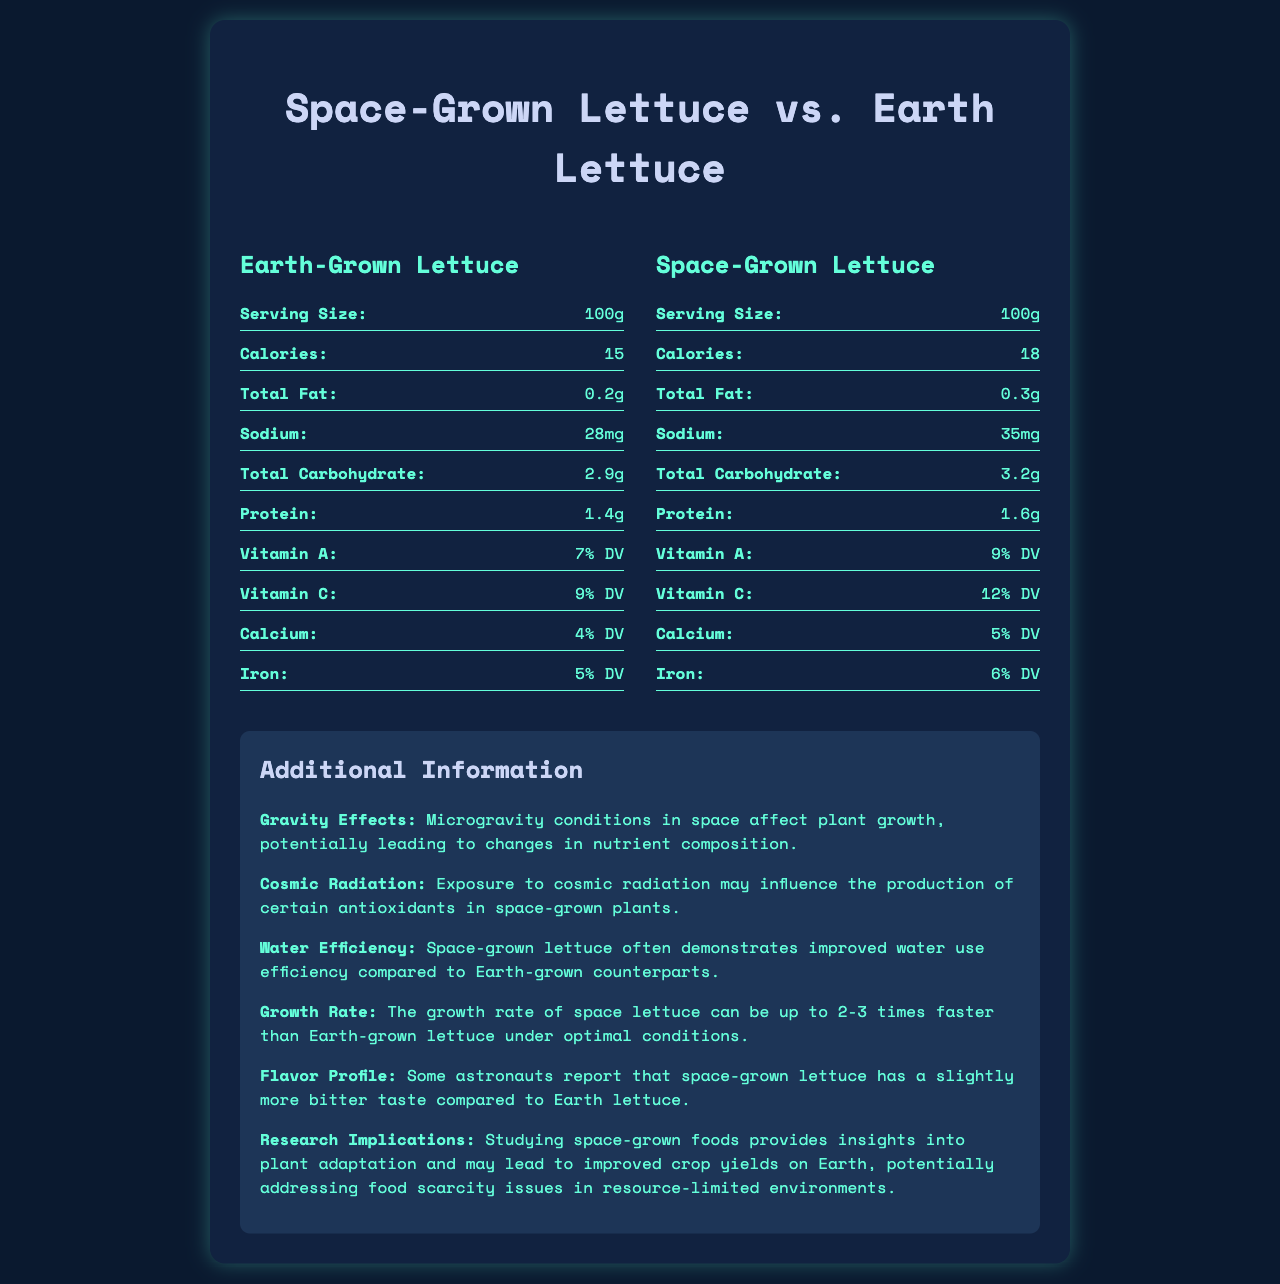what is the serving size for both Earth-grown and space-grown lettuce? The document specifies the serving size as "100g" for both Earth-grown and space-grown lettuce.
Answer: 100g how many calories are in space-grown lettuce? Space-grown lettuce contains 18 calories per 100g serving, as indicated in the document.
Answer: 18 calories compare the total fat content between Earth-grown and space-grown lettuce. The document shows that space-grown lettuce has 0.1g more total fat than Earth-grown lettuce.
Answer: Earth-grown lettuce has 0.2g of total fat, whereas space-grown lettuce has 0.3g of total fat. what is the sodium content in Earth-grown lettuce? The sodium content in Earth-grown lettuce is listed as 28mg.
Answer: 28mg how much potassium is present in space-grown lettuce? Space-grown lettuce contains 220mg of potassium, as shown in the document.
Answer: 220mg which lettuce type has a higher protein content? A. Earth-grown B. Space-grown The protein content in space-grown lettuce is 1.6g, while Earth-grown lettuce has 1.4g of protein.
Answer: B. Space-grown which vitamin content is higher in space-grown lettuce compared to Earth-grown lettuce? A. Vitamin A B. Vitamin C C. Both A and B Space-grown lettuce has higher percentages of both Vitamin A (9% DV) and Vitamin C (12% DV) compared to Earth-grown lettuce, which has Vitamin A (7% DV) and Vitamin C (9% DV).
Answer: C. Both A and B true or false: space-grown lettuce contains saturated and trans fats. Both Earth-grown and space-grown lettuce contain 0g of saturated and trans fats, indicating that space-grown lettuce does not contain these types of fats.
Answer: False summarize the main information provided in the document. The document provides a comparative nutritional analysis between space-grown and Earth-grown lettuce, highlighting differences in their nutrient compositions and additional insights about the impact of space conditions on plant growth.
Answer: The document compares the nutrient content of space-grown lettuce and Earth-grown lettuce per 100g serving. It lists values for calories, total fat, sodium, total carbohydrate, protein, various vitamins, and minerals. Additionally, it provides supplementary information about the effects of microgravity, cosmic radiation, water efficiency, growth rates, flavor profiles, and research implications of growing lettuce in space. what percentage of the daily value of calcium is provided by space-grown lettuce? The document indicates that space-grown lettuce provides 5% of the daily value of calcium.
Answer: 5% DV which lettuce type uses water more efficiently according to the document? The additional information section mentions that space-grown lettuce demonstrates improved water use efficiency compared to Earth-grown counterparts.
Answer: Space-grown lettuce how much more iron does space-grown lettuce contain compared to Earth-grown lettuce? Space-grown lettuce contains 6% DV of iron, whereas Earth-grown lettuce contains 5% DV, showing a difference of 1% DV.
Answer: 1% DV more what are the effects of cosmic radiation on space-grown plants? The document specifies that exposure to cosmic radiation may influence the production of certain antioxidants in space-grown plants.
Answer: May influence the production of certain antioxidants is it mentioned whether the lettuce types affect the flavor profile of astronauts? The document states that some astronauts report that space-grown lettuce has a slightly more bitter taste compared to Earth lettuce.
Answer: Yes what is the growth rate difference between space-grown and Earth-grown lettuce? The additional information section details that the growth rate of space-grown lettuce can be up to 2-3 times faster than Earth-grown lettuce under optimal conditions.
Answer: Space-grown lettuce can grow 2-3 times faster under optimal conditions How does the study of space-grown foods potentially benefit Earth? The document explains that studying space-grown foods provides insights into plant adaptation and may lead to improved crop yields on Earth, potentially addressing food scarcity in resource-limited environments.
Answer: May lead to improved crop yields on Earth, addressing food scarcity What is the exact amount of dietary fiber in both lettuce types? The document provides the dietary fiber content as 1.3g for Earth-grown and 1.5g for space-grown lettuce, but the question asks for an exact amount, implying a need for further precision or total quantities given instead of per 100g servings.
Answer: Cannot be determined 